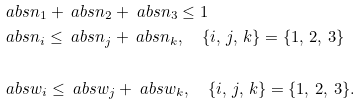Convert formula to latex. <formula><loc_0><loc_0><loc_500><loc_500>& \ a b s { n _ { 1 } } + \ a b s { n _ { 2 } } + \ a b s { n _ { 3 } } \leq 1 \\ & \ a b s { n _ { i } } \leq \ a b s { n _ { j } } + \ a b s { n _ { k } } , \quad \{ i , \, j , \, k \} = \{ 1 , \, 2 , \, 3 \} \\ \\ & \ a b s { w _ { i } } \leq \ a b s { w _ { j } } + \ a b s { w _ { k } } , \quad \{ i , \, j , \, k \} = \{ 1 , \, 2 , \, 3 \} .</formula> 